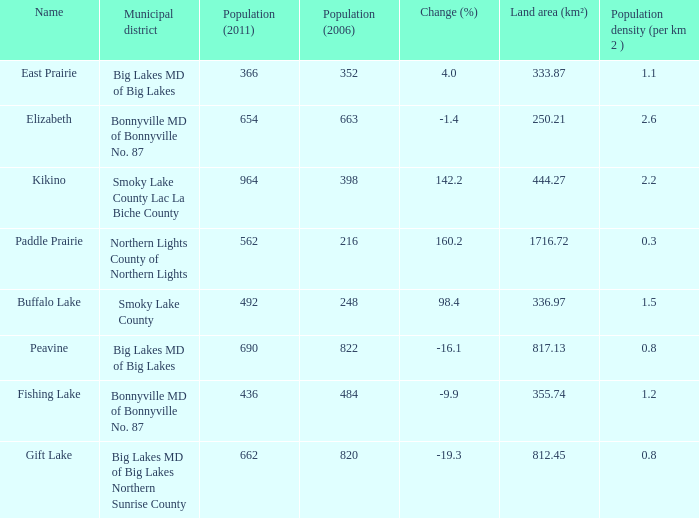What is the population density in Buffalo Lake? 1.5. Help me parse the entirety of this table. {'header': ['Name', 'Municipal district', 'Population (2011)', 'Population (2006)', 'Change (%)', 'Land area (km²)', 'Population density (per km 2 )'], 'rows': [['East Prairie', 'Big Lakes MD of Big Lakes', '366', '352', '4.0', '333.87', '1.1'], ['Elizabeth', 'Bonnyville MD of Bonnyville No. 87', '654', '663', '-1.4', '250.21', '2.6'], ['Kikino', 'Smoky Lake County Lac La Biche County', '964', '398', '142.2', '444.27', '2.2'], ['Paddle Prairie', 'Northern Lights County of Northern Lights', '562', '216', '160.2', '1716.72', '0.3'], ['Buffalo Lake', 'Smoky Lake County', '492', '248', '98.4', '336.97', '1.5'], ['Peavine', 'Big Lakes MD of Big Lakes', '690', '822', '-16.1', '817.13', '0.8'], ['Fishing Lake', 'Bonnyville MD of Bonnyville No. 87', '436', '484', '-9.9', '355.74', '1.2'], ['Gift Lake', 'Big Lakes MD of Big Lakes Northern Sunrise County', '662', '820', '-19.3', '812.45', '0.8']]} 